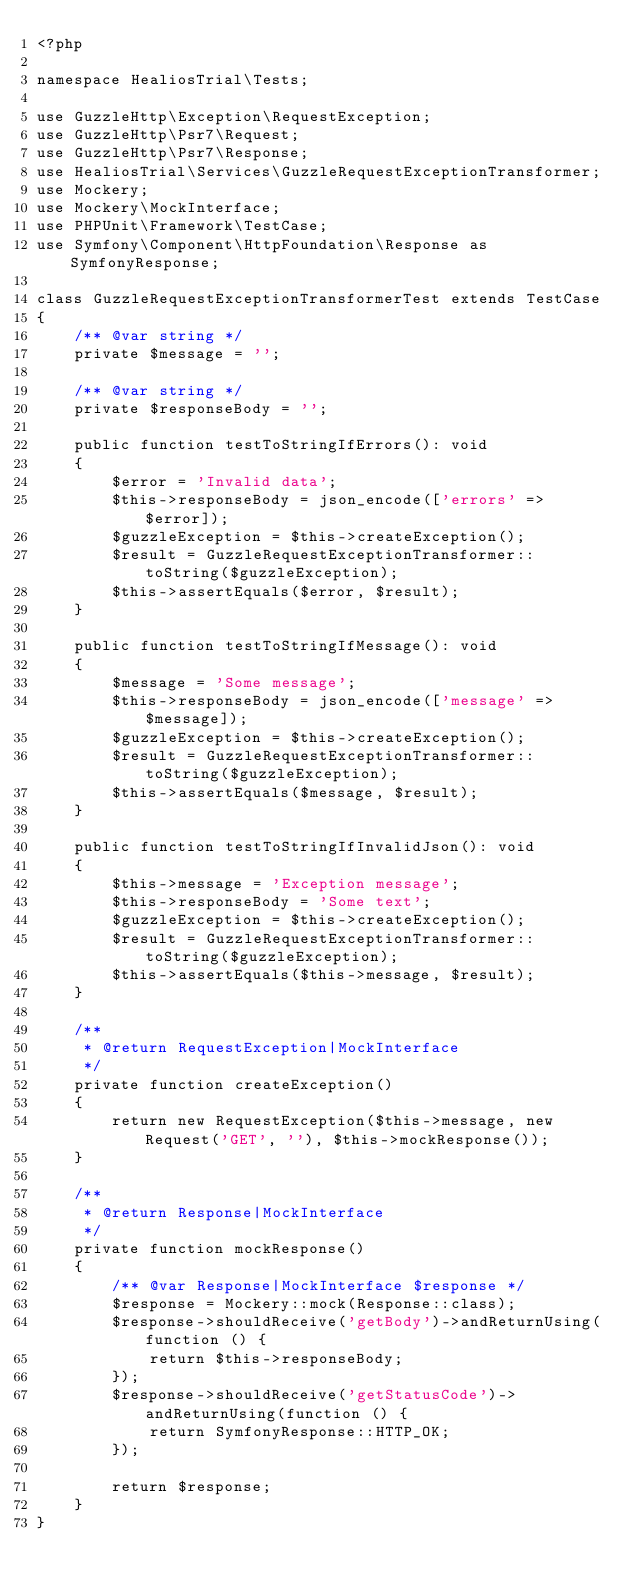Convert code to text. <code><loc_0><loc_0><loc_500><loc_500><_PHP_><?php

namespace HealiosTrial\Tests;

use GuzzleHttp\Exception\RequestException;
use GuzzleHttp\Psr7\Request;
use GuzzleHttp\Psr7\Response;
use HealiosTrial\Services\GuzzleRequestExceptionTransformer;
use Mockery;
use Mockery\MockInterface;
use PHPUnit\Framework\TestCase;
use Symfony\Component\HttpFoundation\Response as SymfonyResponse;

class GuzzleRequestExceptionTransformerTest extends TestCase
{
    /** @var string */
    private $message = '';

    /** @var string */
    private $responseBody = '';

    public function testToStringIfErrors(): void
    {
        $error = 'Invalid data';
        $this->responseBody = json_encode(['errors' => $error]);
        $guzzleException = $this->createException();
        $result = GuzzleRequestExceptionTransformer::toString($guzzleException);
        $this->assertEquals($error, $result);
    }

    public function testToStringIfMessage(): void
    {
        $message = 'Some message';
        $this->responseBody = json_encode(['message' => $message]);
        $guzzleException = $this->createException();
        $result = GuzzleRequestExceptionTransformer::toString($guzzleException);
        $this->assertEquals($message, $result);
    }

    public function testToStringIfInvalidJson(): void
    {
        $this->message = 'Exception message';
        $this->responseBody = 'Some text';
        $guzzleException = $this->createException();
        $result = GuzzleRequestExceptionTransformer::toString($guzzleException);
        $this->assertEquals($this->message, $result);
    }

    /**
     * @return RequestException|MockInterface
     */
    private function createException()
    {
        return new RequestException($this->message, new Request('GET', ''), $this->mockResponse());
    }

    /**
     * @return Response|MockInterface
     */
    private function mockResponse()
    {
        /** @var Response|MockInterface $response */
        $response = Mockery::mock(Response::class);
        $response->shouldReceive('getBody')->andReturnUsing(function () {
            return $this->responseBody;
        });
        $response->shouldReceive('getStatusCode')->andReturnUsing(function () {
            return SymfonyResponse::HTTP_OK;
        });

        return $response;
    }
}
</code> 